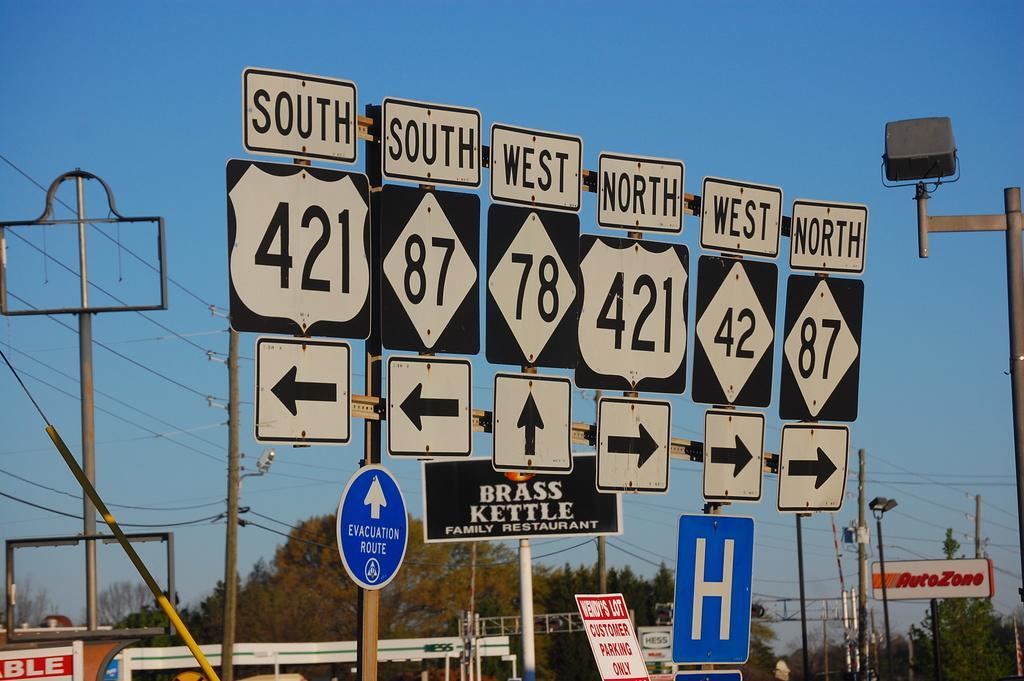<image>
Offer a succinct explanation of the picture presented. the letter H is on the sign outside 